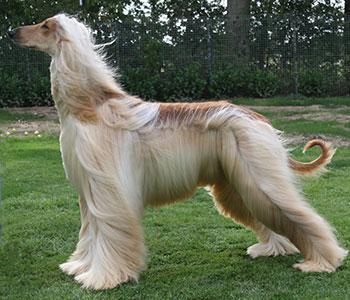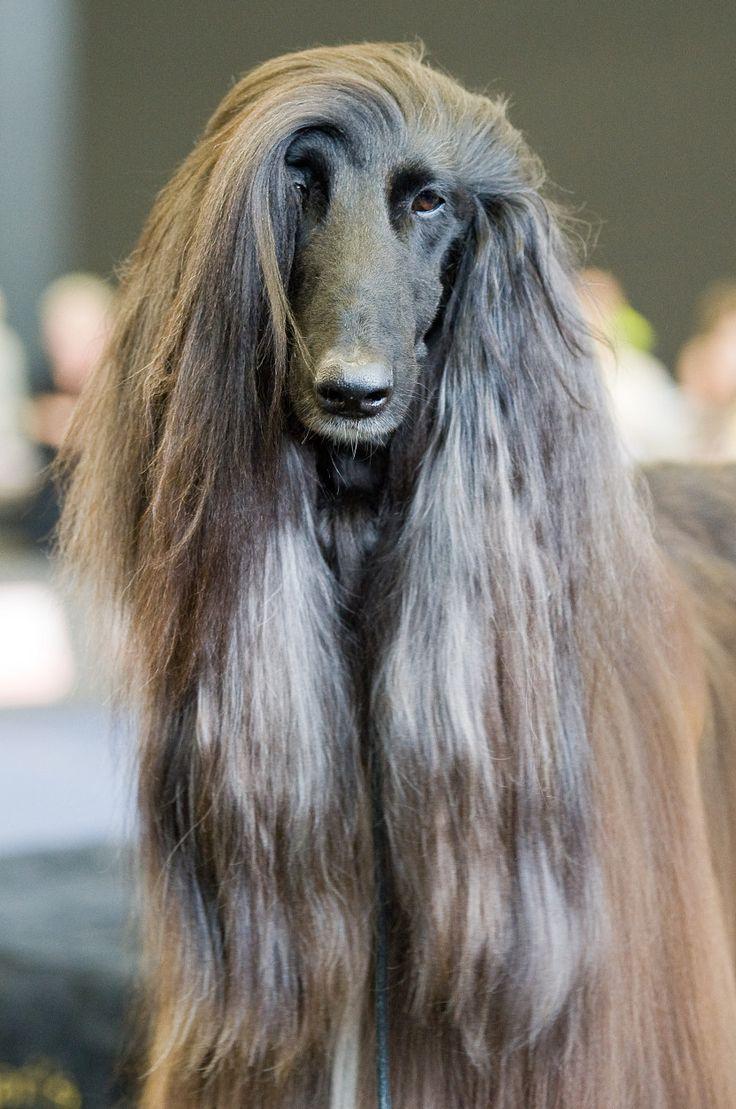The first image is the image on the left, the second image is the image on the right. For the images displayed, is the sentence "The dog in the image on the left is standing on all fours and facing left." factually correct? Answer yes or no. Yes. The first image is the image on the left, the second image is the image on the right. Given the left and right images, does the statement "A hound poses in profile facing left, in the left image." hold true? Answer yes or no. Yes. 